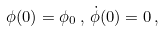<formula> <loc_0><loc_0><loc_500><loc_500>\phi ( 0 ) = \phi _ { 0 } \, , \, \dot { \phi } ( 0 ) = 0 \, ,</formula> 